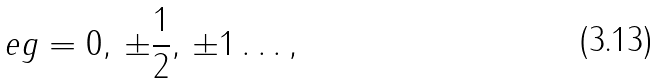<formula> <loc_0><loc_0><loc_500><loc_500>e g = 0 , \, \pm \frac { 1 } { 2 } , \, \pm 1 \dots ,</formula> 